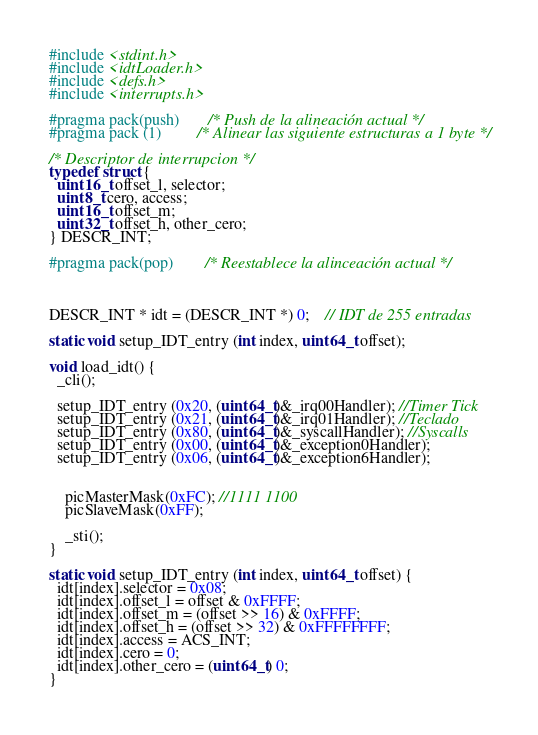<code> <loc_0><loc_0><loc_500><loc_500><_C_>#include <stdint.h>
#include <idtLoader.h>
#include <defs.h>
#include <interrupts.h>

#pragma pack(push)		/* Push de la alineación actual */
#pragma pack (1) 		/* Alinear las siguiente estructuras a 1 byte */

/* Descriptor de interrupcion */
typedef struct {
  uint16_t offset_l, selector;
  uint8_t cero, access;
  uint16_t offset_m;
  uint32_t offset_h, other_cero;
} DESCR_INT;

#pragma pack(pop)		/* Reestablece la alinceación actual */



DESCR_INT * idt = (DESCR_INT *) 0;	// IDT de 255 entradas

static void setup_IDT_entry (int index, uint64_t offset);

void load_idt() {
  _cli();

  setup_IDT_entry (0x20, (uint64_t)&_irq00Handler); //Timer Tick
  setup_IDT_entry (0x21, (uint64_t)&_irq01Handler); //Teclado
  setup_IDT_entry (0x80, (uint64_t)&_syscallHandler); //Syscalls
  setup_IDT_entry (0x00, (uint64_t)&_exception0Handler);
  setup_IDT_entry (0x06, (uint64_t)&_exception6Handler);


	picMasterMask(0xFC); //1111 1100
	picSlaveMask(0xFF);

	_sti();
}

static void setup_IDT_entry (int index, uint64_t offset) {
  idt[index].selector = 0x08;
  idt[index].offset_l = offset & 0xFFFF;
  idt[index].offset_m = (offset >> 16) & 0xFFFF;
  idt[index].offset_h = (offset >> 32) & 0xFFFFFFFF;
  idt[index].access = ACS_INT;
  idt[index].cero = 0;
  idt[index].other_cero = (uint64_t) 0;
}
</code> 